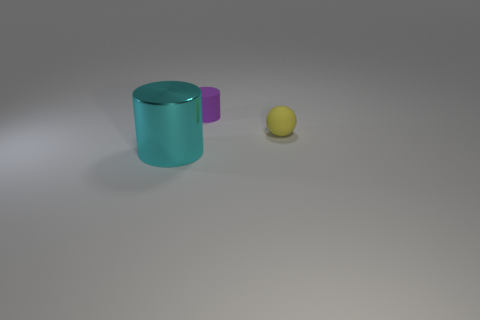Are there any other things that are the same material as the large cyan thing?
Provide a short and direct response. No. How many purple objects are the same size as the cyan object?
Offer a terse response. 0. How many tiny objects are either metal cylinders or brown spheres?
Provide a succinct answer. 0. Are any gray shiny cylinders visible?
Your answer should be very brief. No. Are there more matte objects that are to the right of the tiny rubber cylinder than big shiny cylinders that are in front of the cyan cylinder?
Make the answer very short. Yes. What is the color of the tiny matte thing that is in front of the small rubber thing behind the yellow object?
Offer a terse response. Yellow. There is a cylinder that is left of the tiny rubber thing on the left side of the tiny object that is right of the tiny cylinder; how big is it?
Provide a short and direct response. Large. There is a big cyan shiny object; what shape is it?
Ensure brevity in your answer.  Cylinder. There is a cylinder that is behind the cyan shiny cylinder; how many small yellow matte spheres are behind it?
Your answer should be compact. 0. What number of other things are there of the same material as the purple thing
Your response must be concise. 1. 